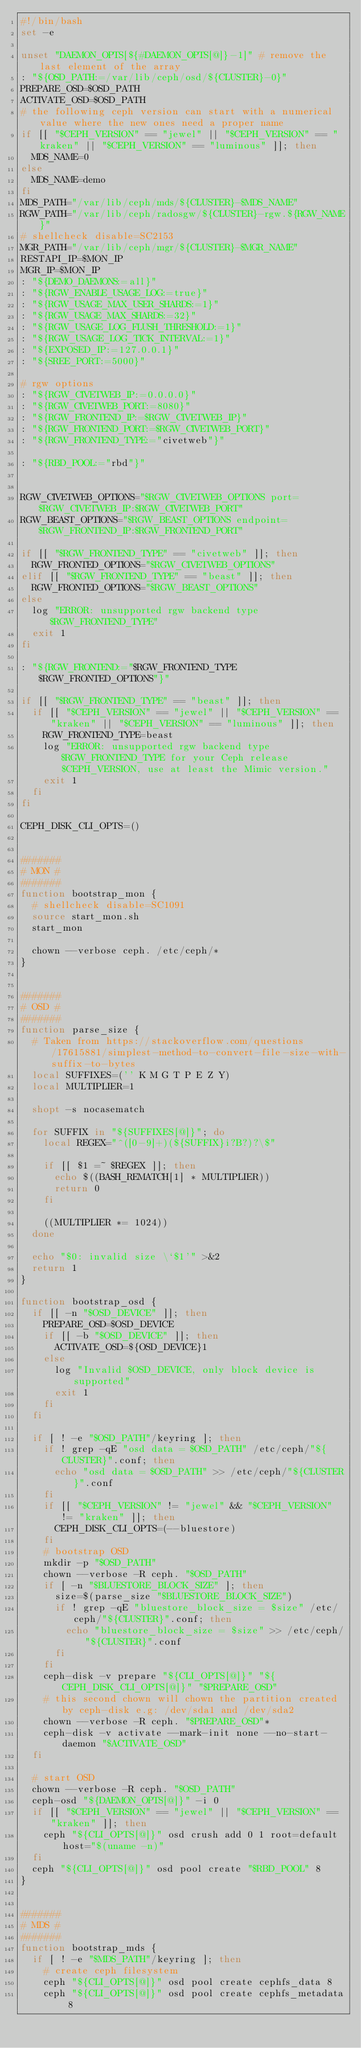Convert code to text. <code><loc_0><loc_0><loc_500><loc_500><_Bash_>#!/bin/bash
set -e

unset "DAEMON_OPTS[${#DAEMON_OPTS[@]}-1]" # remove the last element of the array
: "${OSD_PATH:=/var/lib/ceph/osd/${CLUSTER}-0}"
PREPARE_OSD=$OSD_PATH
ACTIVATE_OSD=$OSD_PATH
# the following ceph version can start with a numerical value where the new ones need a proper name
if [[ "$CEPH_VERSION" == "jewel" || "$CEPH_VERSION" == "kraken" || "$CEPH_VERSION" == "luminous" ]]; then
  MDS_NAME=0
else
  MDS_NAME=demo
fi
MDS_PATH="/var/lib/ceph/mds/${CLUSTER}-$MDS_NAME"
RGW_PATH="/var/lib/ceph/radosgw/${CLUSTER}-rgw.${RGW_NAME}"
# shellcheck disable=SC2153
MGR_PATH="/var/lib/ceph/mgr/${CLUSTER}-$MGR_NAME"
RESTAPI_IP=$MON_IP
MGR_IP=$MON_IP
: "${DEMO_DAEMONS:=all}"
: "${RGW_ENABLE_USAGE_LOG:=true}"
: "${RGW_USAGE_MAX_USER_SHARDS:=1}"
: "${RGW_USAGE_MAX_SHARDS:=32}"
: "${RGW_USAGE_LOG_FLUSH_THRESHOLD:=1}"
: "${RGW_USAGE_LOG_TICK_INTERVAL:=1}"
: "${EXPOSED_IP:=127.0.0.1}"
: "${SREE_PORT:=5000}"

# rgw options
: "${RGW_CIVETWEB_IP:=0.0.0.0}"
: "${RGW_CIVETWEB_PORT:=8080}"
: "${RGW_FRONTEND_IP:=$RGW_CIVETWEB_IP}"
: "${RGW_FRONTEND_PORT:=$RGW_CIVETWEB_PORT}"
: "${RGW_FRONTEND_TYPE:="civetweb"}"

: "${RBD_POOL:="rbd"}"


RGW_CIVETWEB_OPTIONS="$RGW_CIVETWEB_OPTIONS port=$RGW_CIVETWEB_IP:$RGW_CIVETWEB_PORT"
RGW_BEAST_OPTIONS="$RGW_BEAST_OPTIONS endpoint=$RGW_FRONTEND_IP:$RGW_FRONTEND_PORT"

if [[ "$RGW_FRONTEND_TYPE" == "civetweb" ]]; then
  RGW_FRONTED_OPTIONS="$RGW_CIVETWEB_OPTIONS"
elif [[ "$RGW_FRONTEND_TYPE" == "beast" ]]; then
  RGW_FRONTED_OPTIONS="$RGW_BEAST_OPTIONS"
else
  log "ERROR: unsupported rgw backend type $RGW_FRONTEND_TYPE"
  exit 1
fi

: "${RGW_FRONTEND:="$RGW_FRONTEND_TYPE $RGW_FRONTED_OPTIONS"}"

if [[ "$RGW_FRONTEND_TYPE" == "beast" ]]; then
  if [[ "$CEPH_VERSION" == "jewel" || "$CEPH_VERSION" == "kraken" || "$CEPH_VERSION" == "luminous" ]]; then
    RGW_FRONTEND_TYPE=beast
    log "ERROR: unsupported rgw backend type $RGW_FRONTEND_TYPE for your Ceph release $CEPH_VERSION, use at least the Mimic version."
    exit 1
  fi
fi

CEPH_DISK_CLI_OPTS=()


#######
# MON #
#######
function bootstrap_mon {
  # shellcheck disable=SC1091
  source start_mon.sh
  start_mon

  chown --verbose ceph. /etc/ceph/*
}


#######
# OSD #
#######
function parse_size {
  # Taken from https://stackoverflow.com/questions/17615881/simplest-method-to-convert-file-size-with-suffix-to-bytes
  local SUFFIXES=('' K M G T P E Z Y)
  local MULTIPLIER=1

  shopt -s nocasematch

  for SUFFIX in "${SUFFIXES[@]}"; do
    local REGEX="^([0-9]+)(${SUFFIX}i?B?)?\$"

    if [[ $1 =~ $REGEX ]]; then
      echo $((BASH_REMATCH[1] * MULTIPLIER))
      return 0
    fi

    ((MULTIPLIER *= 1024))
  done

  echo "$0: invalid size \`$1'" >&2
  return 1
}

function bootstrap_osd {
  if [[ -n "$OSD_DEVICE" ]]; then
    PREPARE_OSD=$OSD_DEVICE
    if [[ -b "$OSD_DEVICE" ]]; then
      ACTIVATE_OSD=${OSD_DEVICE}1
    else
      log "Invalid $OSD_DEVICE, only block device is supported"
      exit 1
    fi
  fi

  if [ ! -e "$OSD_PATH"/keyring ]; then
    if ! grep -qE "osd data = $OSD_PATH" /etc/ceph/"${CLUSTER}".conf; then
      echo "osd data = $OSD_PATH" >> /etc/ceph/"${CLUSTER}".conf
    fi
    if [[ "$CEPH_VERSION" != "jewel" && "$CEPH_VERSION" != "kraken" ]]; then
      CEPH_DISK_CLI_OPTS=(--bluestore)
    fi
    # bootstrap OSD
    mkdir -p "$OSD_PATH"
    chown --verbose -R ceph. "$OSD_PATH"
    if [ -n "$BLUESTORE_BLOCK_SIZE" ]; then
      size=$(parse_size "$BLUESTORE_BLOCK_SIZE")
      if ! grep -qE "bluestore_block_size = $size" /etc/ceph/"${CLUSTER}".conf; then
        echo "bluestore_block_size = $size" >> /etc/ceph/"${CLUSTER}".conf
      fi
    fi
    ceph-disk -v prepare "${CLI_OPTS[@]}" "${CEPH_DISK_CLI_OPTS[@]}" "$PREPARE_OSD"
    # this second chown will chown the partition created by ceph-disk e.g: /dev/sda1 and /dev/sda2
    chown --verbose -R ceph. "$PREPARE_OSD"*
    ceph-disk -v activate --mark-init none --no-start-daemon "$ACTIVATE_OSD"
  fi

  # start OSD
  chown --verbose -R ceph. "$OSD_PATH"
  ceph-osd "${DAEMON_OPTS[@]}" -i 0
  if [[ "$CEPH_VERSION" == "jewel" || "$CEPH_VERSION" == "kraken" ]]; then
    ceph "${CLI_OPTS[@]}" osd crush add 0 1 root=default host="$(uname -n)"
  fi
  ceph "${CLI_OPTS[@]}" osd pool create "$RBD_POOL" 8
}


#######
# MDS #
#######
function bootstrap_mds {
  if [ ! -e "$MDS_PATH"/keyring ]; then
    # create ceph filesystem
    ceph "${CLI_OPTS[@]}" osd pool create cephfs_data 8
    ceph "${CLI_OPTS[@]}" osd pool create cephfs_metadata 8</code> 